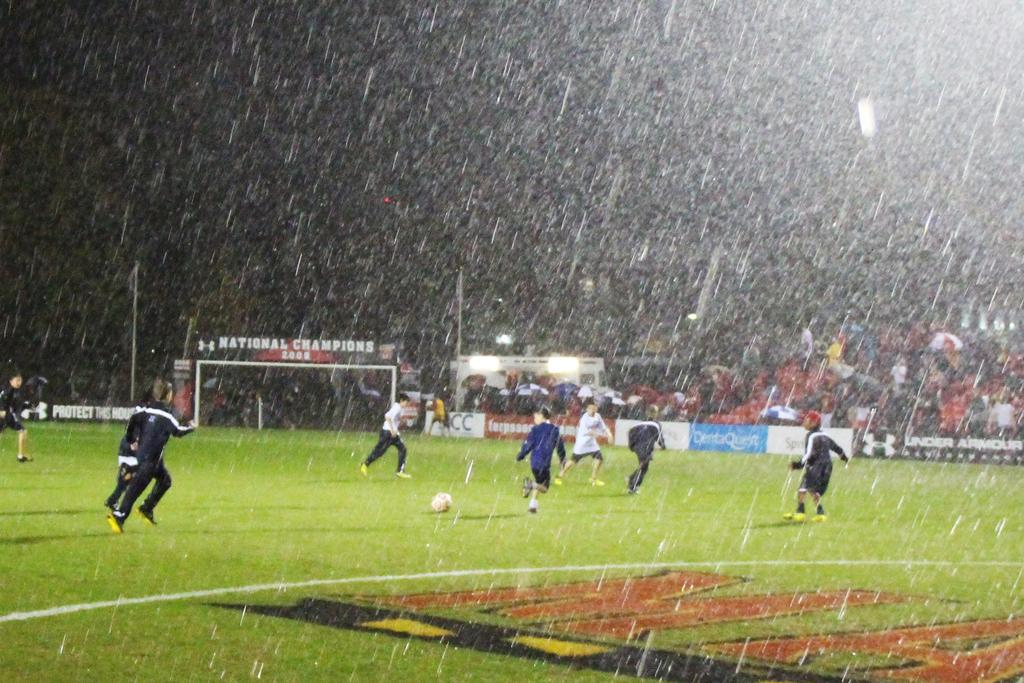<image>
Create a compact narrative representing the image presented. Several soccer players are on the field in the rain, with an advertisement for Under Armour on the wall which says "protect this house" 